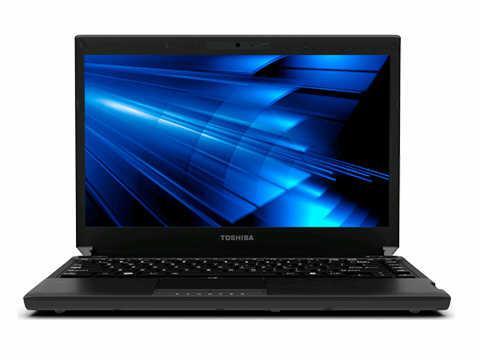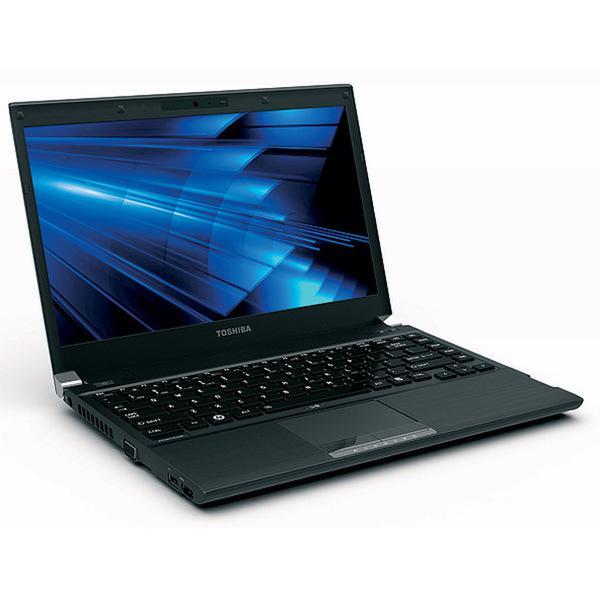The first image is the image on the left, the second image is the image on the right. Analyze the images presented: Is the assertion "The computer displays have the same background image." valid? Answer yes or no. Yes. The first image is the image on the left, the second image is the image on the right. Given the left and right images, does the statement "The open laptop on the left is viewed head-on, and the open laptop on the right is displayed at an angle." hold true? Answer yes or no. Yes. 